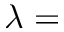<formula> <loc_0><loc_0><loc_500><loc_500>\lambda =</formula> 